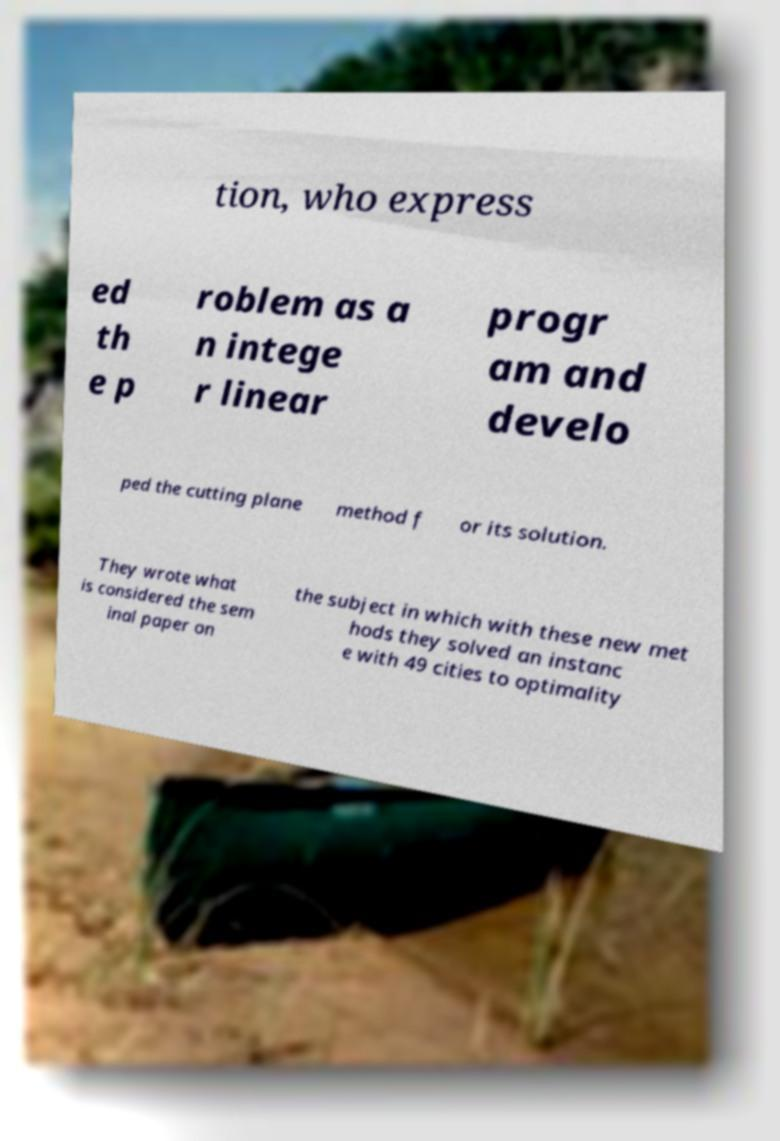There's text embedded in this image that I need extracted. Can you transcribe it verbatim? tion, who express ed th e p roblem as a n intege r linear progr am and develo ped the cutting plane method f or its solution. They wrote what is considered the sem inal paper on the subject in which with these new met hods they solved an instanc e with 49 cities to optimality 